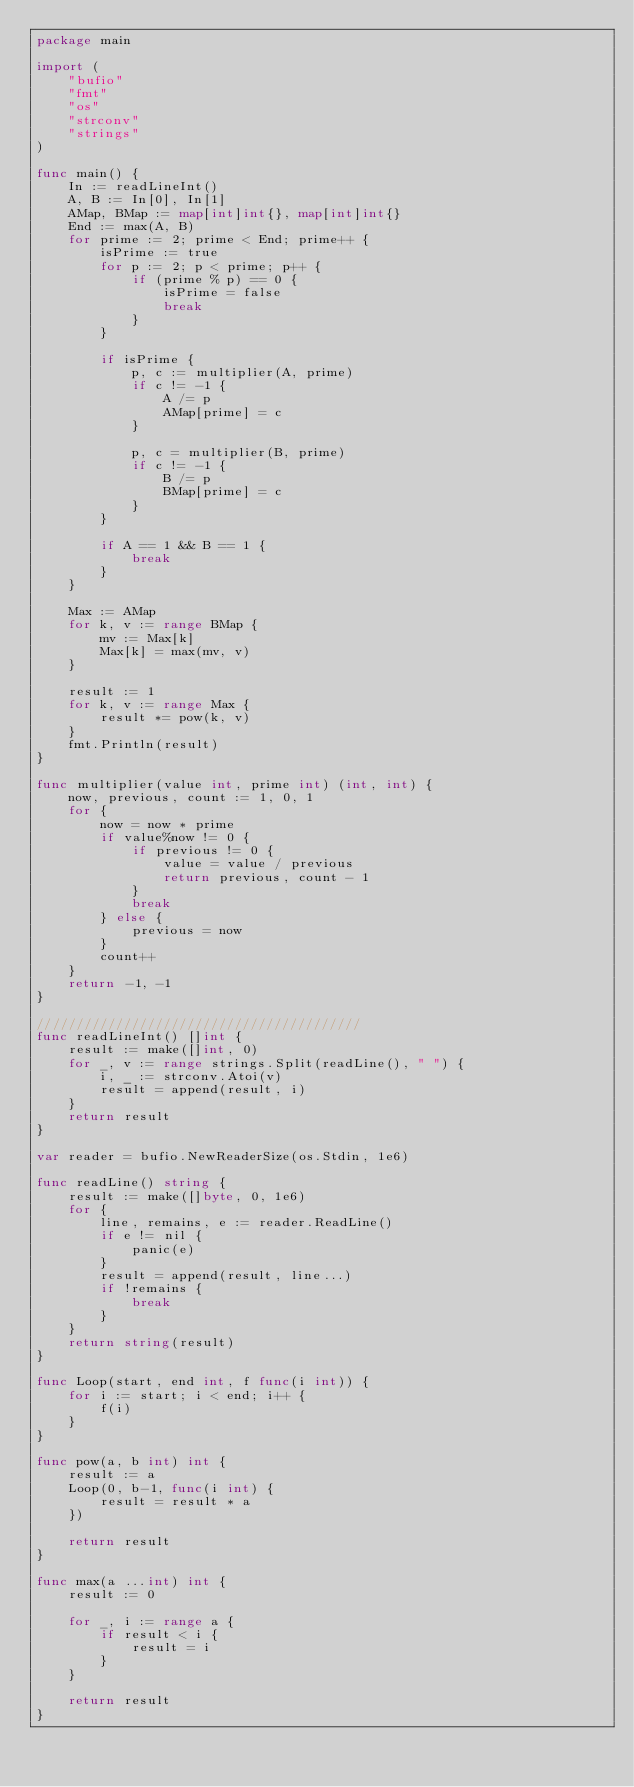<code> <loc_0><loc_0><loc_500><loc_500><_Go_>package main

import (
	"bufio"
	"fmt"
	"os"
	"strconv"
	"strings"
)

func main() {
	In := readLineInt()
	A, B := In[0], In[1]
	AMap, BMap := map[int]int{}, map[int]int{}
	End := max(A, B)
	for prime := 2; prime < End; prime++ {
		isPrime := true
		for p := 2; p < prime; p++ {
			if (prime % p) == 0 {
				isPrime = false
				break
			}
		}

		if isPrime {
			p, c := multiplier(A, prime)
			if c != -1 {
				A /= p
				AMap[prime] = c
			}

			p, c = multiplier(B, prime)
			if c != -1 {
				B /= p
				BMap[prime] = c
			}
		}

		if A == 1 && B == 1 {
			break
		}
	}

	Max := AMap
	for k, v := range BMap {
		mv := Max[k]
		Max[k] = max(mv, v)
	}

	result := 1
	for k, v := range Max {
		result *= pow(k, v)
	}
	fmt.Println(result)
}

func multiplier(value int, prime int) (int, int) {
	now, previous, count := 1, 0, 1
	for {
		now = now * prime
		if value%now != 0 {
			if previous != 0 {
				value = value / previous
				return previous, count - 1
			}
			break
		} else {
			previous = now
		}
		count++
	}
	return -1, -1
}

/////////////////////////////////////////
func readLineInt() []int {
	result := make([]int, 0)
	for _, v := range strings.Split(readLine(), " ") {
		i, _ := strconv.Atoi(v)
		result = append(result, i)
	}
	return result
}

var reader = bufio.NewReaderSize(os.Stdin, 1e6)

func readLine() string {
	result := make([]byte, 0, 1e6)
	for {
		line, remains, e := reader.ReadLine()
		if e != nil {
			panic(e)
		}
		result = append(result, line...)
		if !remains {
			break
		}
	}
	return string(result)
}

func Loop(start, end int, f func(i int)) {
	for i := start; i < end; i++ {
		f(i)
	}
}

func pow(a, b int) int {
	result := a
	Loop(0, b-1, func(i int) {
		result = result * a
	})

	return result
}

func max(a ...int) int {
	result := 0

	for _, i := range a {
		if result < i {
			result = i
		}
	}

	return result
}
</code> 